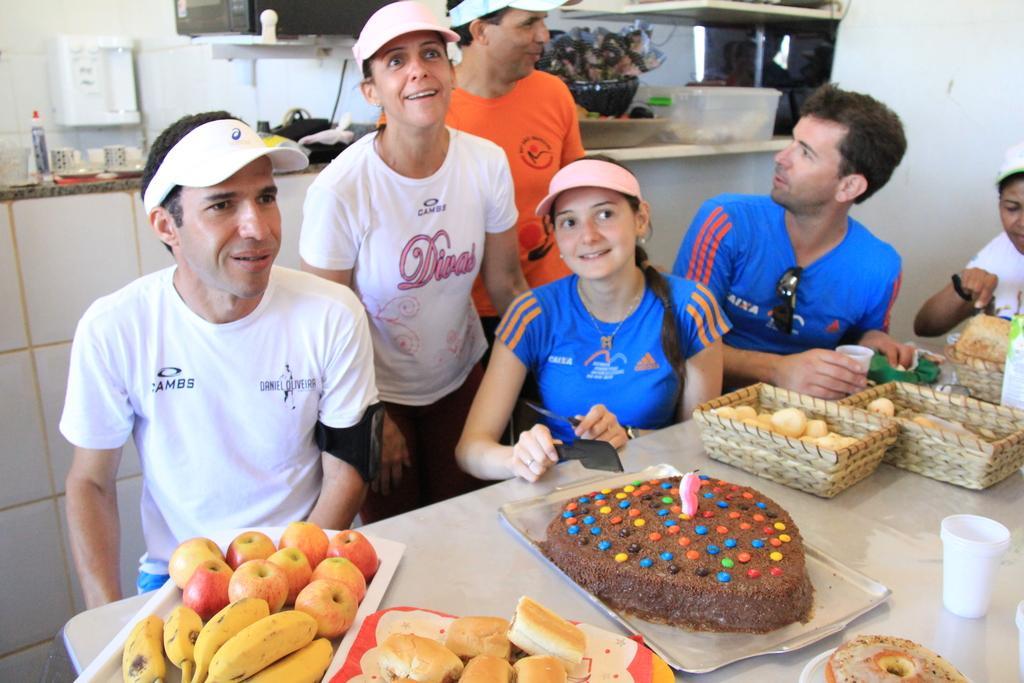Can you describe this image briefly? In this image there is a table. There are food items like bananas, apples, biscuits, cake. There are glasses. There are trays. There are people. There is a counter in the background. There are cups, bottles. There are some objects and boxes. 